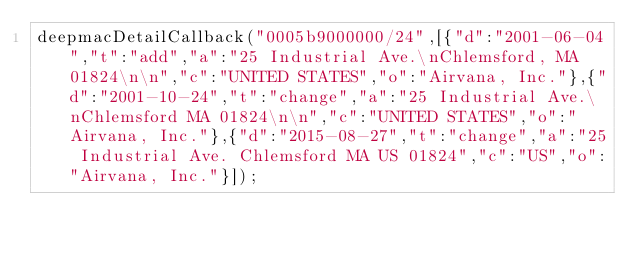<code> <loc_0><loc_0><loc_500><loc_500><_JavaScript_>deepmacDetailCallback("0005b9000000/24",[{"d":"2001-06-04","t":"add","a":"25 Industrial Ave.\nChlemsford, MA 01824\n\n","c":"UNITED STATES","o":"Airvana, Inc."},{"d":"2001-10-24","t":"change","a":"25 Industrial Ave.\nChlemsford MA 01824\n\n","c":"UNITED STATES","o":"Airvana, Inc."},{"d":"2015-08-27","t":"change","a":"25 Industrial Ave. Chlemsford MA US 01824","c":"US","o":"Airvana, Inc."}]);
</code> 